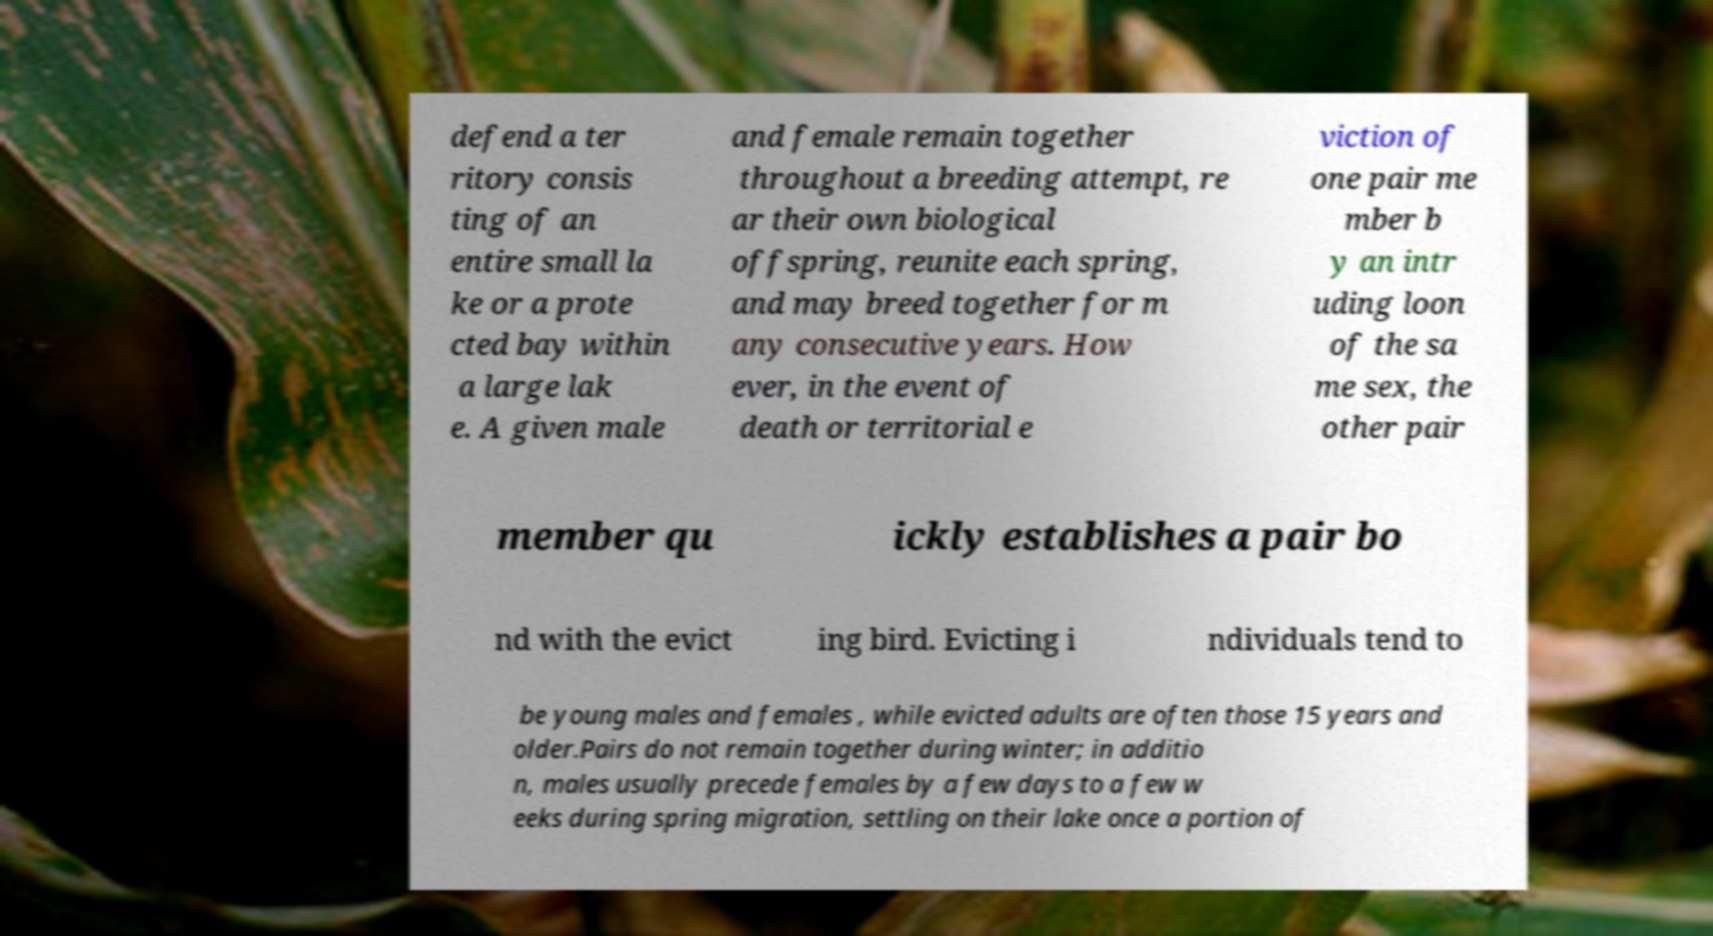Please identify and transcribe the text found in this image. defend a ter ritory consis ting of an entire small la ke or a prote cted bay within a large lak e. A given male and female remain together throughout a breeding attempt, re ar their own biological offspring, reunite each spring, and may breed together for m any consecutive years. How ever, in the event of death or territorial e viction of one pair me mber b y an intr uding loon of the sa me sex, the other pair member qu ickly establishes a pair bo nd with the evict ing bird. Evicting i ndividuals tend to be young males and females , while evicted adults are often those 15 years and older.Pairs do not remain together during winter; in additio n, males usually precede females by a few days to a few w eeks during spring migration, settling on their lake once a portion of 